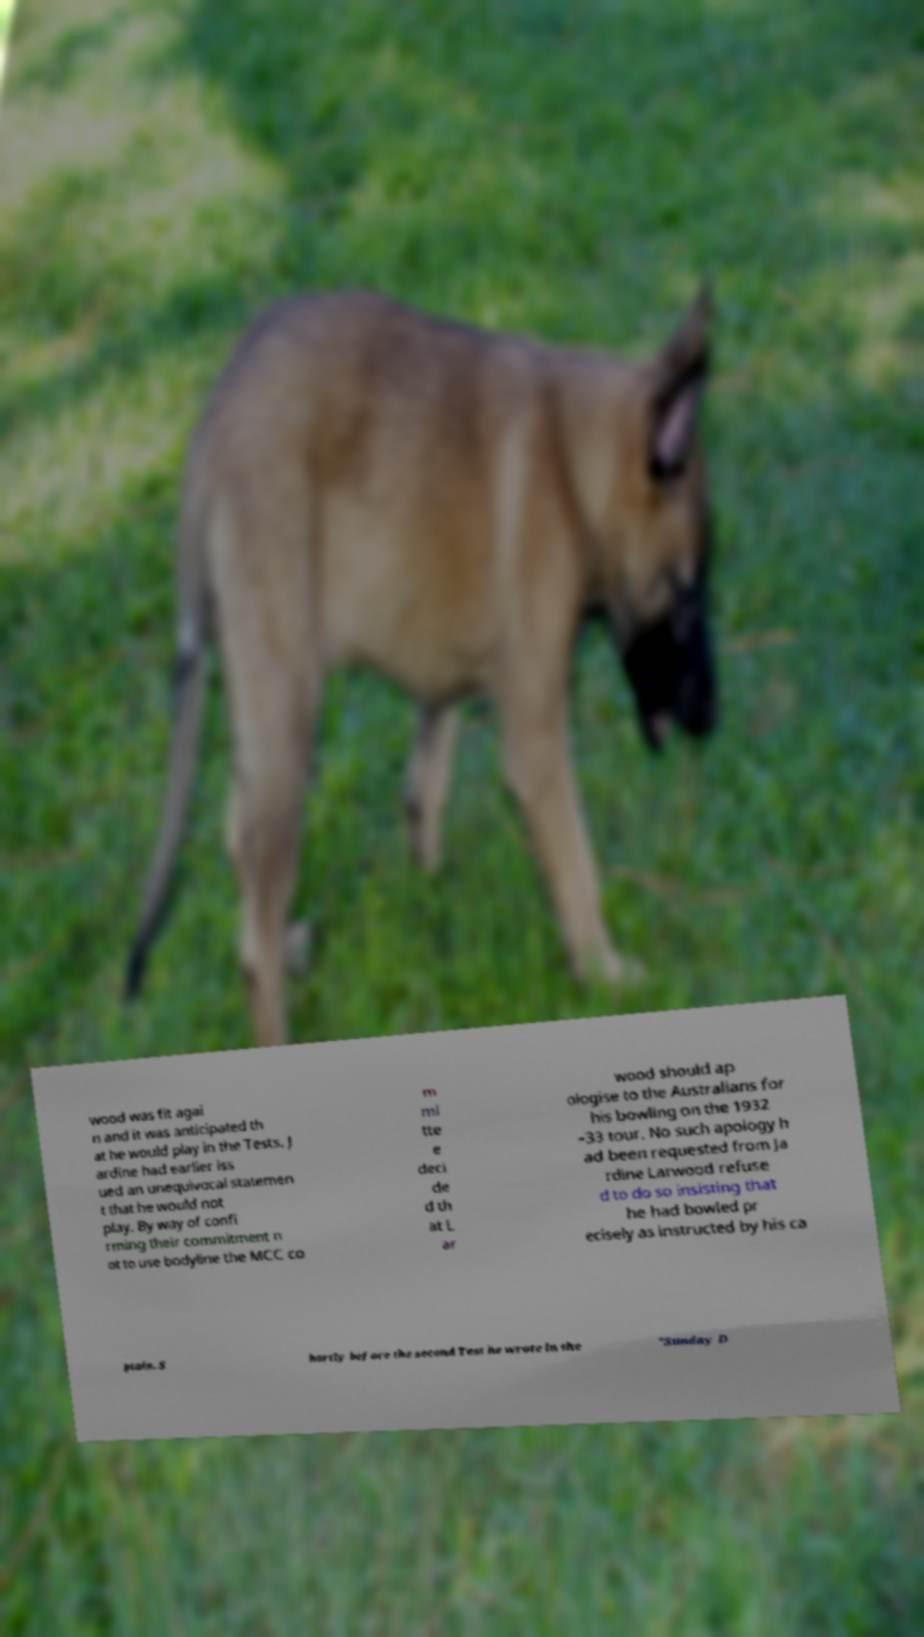For documentation purposes, I need the text within this image transcribed. Could you provide that? wood was fit agai n and it was anticipated th at he would play in the Tests. J ardine had earlier iss ued an unequivocal statemen t that he would not play. By way of confi rming their commitment n ot to use bodyline the MCC co m mi tte e deci de d th at L ar wood should ap ologise to the Australians for his bowling on the 1932 –33 tour. No such apology h ad been requested from Ja rdine Larwood refuse d to do so insisting that he had bowled pr ecisely as instructed by his ca ptain. S hortly before the second Test he wrote in the "Sunday D 